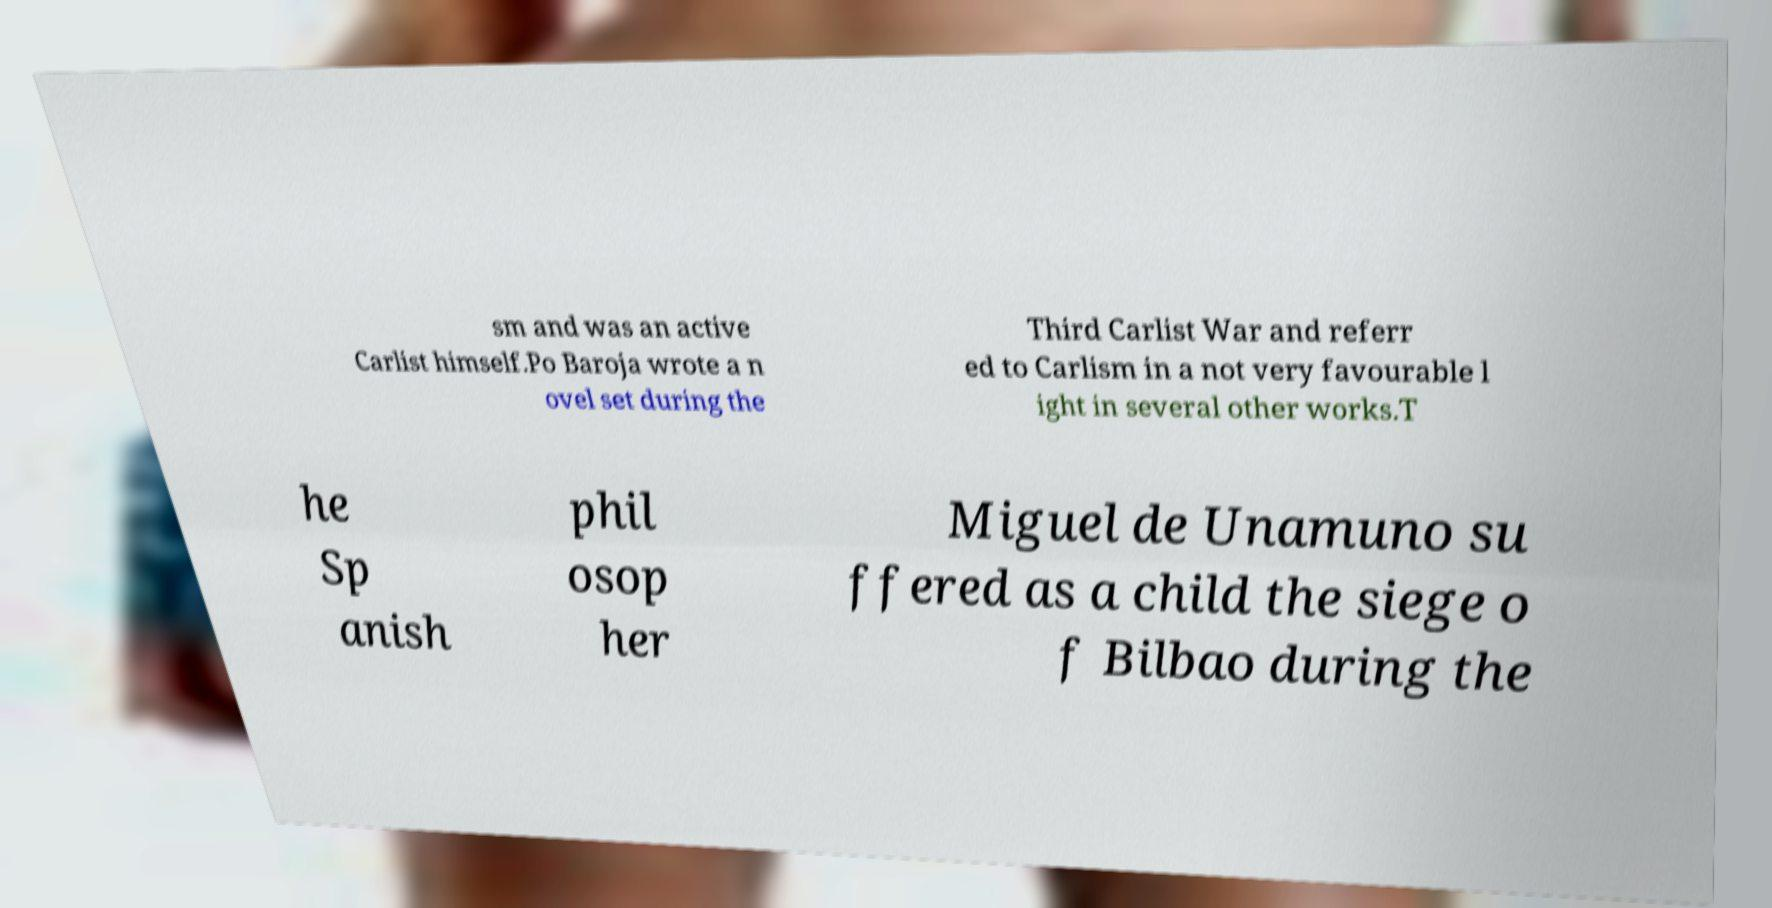Please read and relay the text visible in this image. What does it say? sm and was an active Carlist himself.Po Baroja wrote a n ovel set during the Third Carlist War and referr ed to Carlism in a not very favourable l ight in several other works.T he Sp anish phil osop her Miguel de Unamuno su ffered as a child the siege o f Bilbao during the 